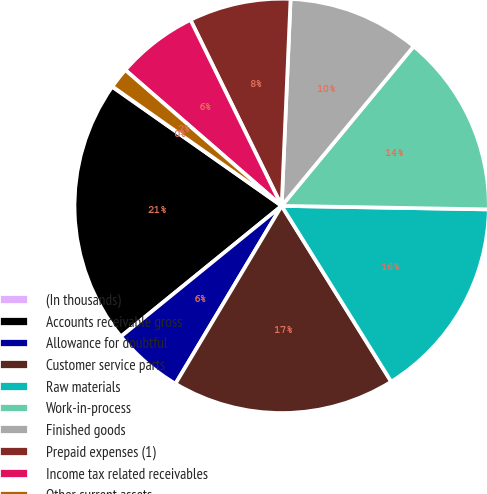Convert chart. <chart><loc_0><loc_0><loc_500><loc_500><pie_chart><fcel>(In thousands)<fcel>Accounts receivable gross<fcel>Allowance for doubtful<fcel>Customer service parts<fcel>Raw materials<fcel>Work-in-process<fcel>Finished goods<fcel>Prepaid expenses (1)<fcel>Income tax related receivables<fcel>Other current assets<nl><fcel>0.03%<fcel>20.61%<fcel>5.57%<fcel>17.44%<fcel>15.86%<fcel>14.27%<fcel>10.32%<fcel>7.94%<fcel>6.36%<fcel>1.61%<nl></chart> 